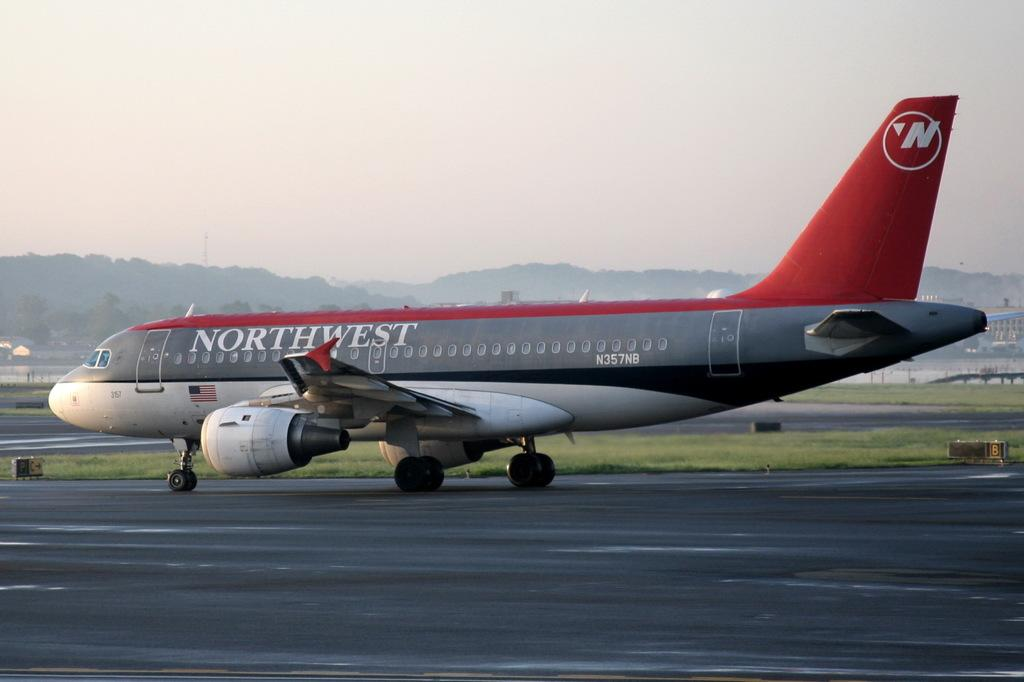<image>
Provide a brief description of the given image. A red and gray Northwest airplane's wheels are touching down 